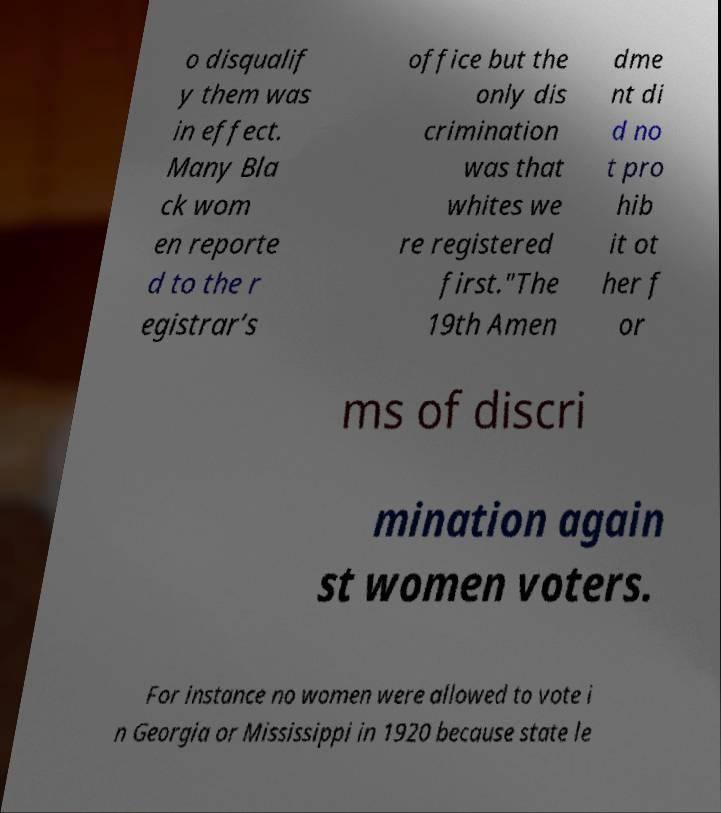Please identify and transcribe the text found in this image. o disqualif y them was in effect. Many Bla ck wom en reporte d to the r egistrar’s office but the only dis crimination was that whites we re registered first."The 19th Amen dme nt di d no t pro hib it ot her f or ms of discri mination again st women voters. For instance no women were allowed to vote i n Georgia or Mississippi in 1920 because state le 